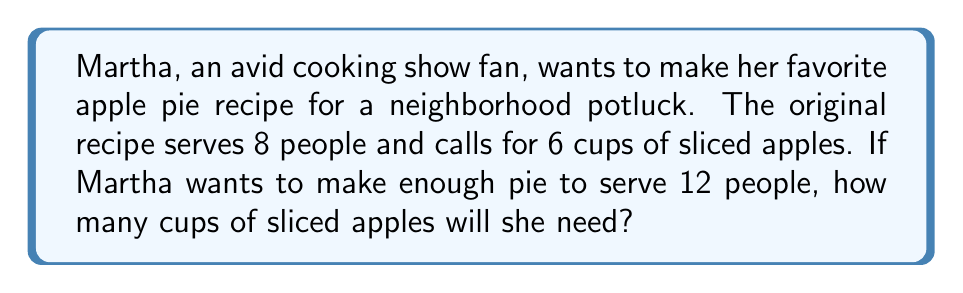What is the answer to this math problem? Let's approach this step-by-step:

1. Understand the given information:
   - Original recipe serves 8 people
   - Original recipe uses 6 cups of sliced apples
   - Martha wants to serve 12 people

2. Calculate the scaling factor:
   $\text{Scaling factor} = \frac{\text{New number of servings}}{\text{Original number of servings}}$
   
   $\text{Scaling factor} = \frac{12}{8} = 1.5$

3. Scale the ingredient:
   New amount = Original amount × Scaling factor
   
   $\text{New amount of apples} = 6 \text{ cups} \times 1.5$

4. Perform the calculation:
   $6 \times 1.5 = 9$

Therefore, Martha will need 9 cups of sliced apples for her scaled-up recipe.
Answer: $9 \text{ cups of sliced apples}$ 